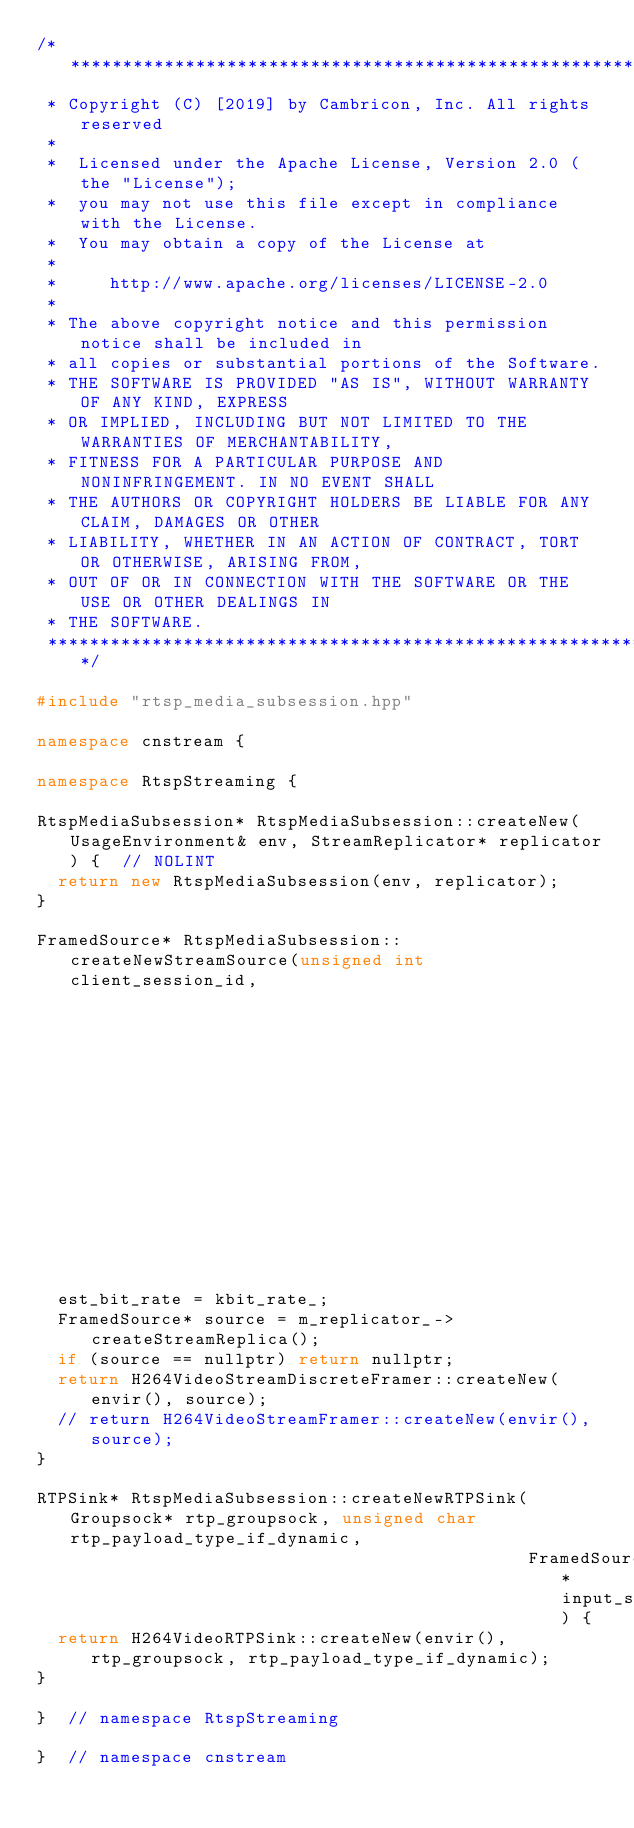<code> <loc_0><loc_0><loc_500><loc_500><_C++_>/*************************************************************************
 * Copyright (C) [2019] by Cambricon, Inc. All rights reserved
 *
 *  Licensed under the Apache License, Version 2.0 (the "License");
 *  you may not use this file except in compliance with the License.
 *  You may obtain a copy of the License at
 *
 *     http://www.apache.org/licenses/LICENSE-2.0
 *
 * The above copyright notice and this permission notice shall be included in
 * all copies or substantial portions of the Software.
 * THE SOFTWARE IS PROVIDED "AS IS", WITHOUT WARRANTY OF ANY KIND, EXPRESS
 * OR IMPLIED, INCLUDING BUT NOT LIMITED TO THE WARRANTIES OF MERCHANTABILITY,
 * FITNESS FOR A PARTICULAR PURPOSE AND NONINFRINGEMENT. IN NO EVENT SHALL
 * THE AUTHORS OR COPYRIGHT HOLDERS BE LIABLE FOR ANY CLAIM, DAMAGES OR OTHER
 * LIABILITY, WHETHER IN AN ACTION OF CONTRACT, TORT OR OTHERWISE, ARISING FROM,
 * OUT OF OR IN CONNECTION WITH THE SOFTWARE OR THE USE OR OTHER DEALINGS IN
 * THE SOFTWARE.
 *************************************************************************/

#include "rtsp_media_subsession.hpp"

namespace cnstream {

namespace RtspStreaming {

RtspMediaSubsession* RtspMediaSubsession::createNew(UsageEnvironment& env, StreamReplicator* replicator) {  // NOLINT
  return new RtspMediaSubsession(env, replicator);
}

FramedSource* RtspMediaSubsession::createNewStreamSource(unsigned int client_session_id,
                                                         unsigned int& est_bit_rate) {  // NOLINT
  est_bit_rate = kbit_rate_;
  FramedSource* source = m_replicator_->createStreamReplica();
  if (source == nullptr) return nullptr;
  return H264VideoStreamDiscreteFramer::createNew(envir(), source);
  // return H264VideoStreamFramer::createNew(envir(), source);
}

RTPSink* RtspMediaSubsession::createNewRTPSink(Groupsock* rtp_groupsock, unsigned char rtp_payload_type_if_dynamic,
                                               FramedSource* input_source) {
  return H264VideoRTPSink::createNew(envir(), rtp_groupsock, rtp_payload_type_if_dynamic);
}

}  // namespace RtspStreaming

}  // namespace cnstream
</code> 